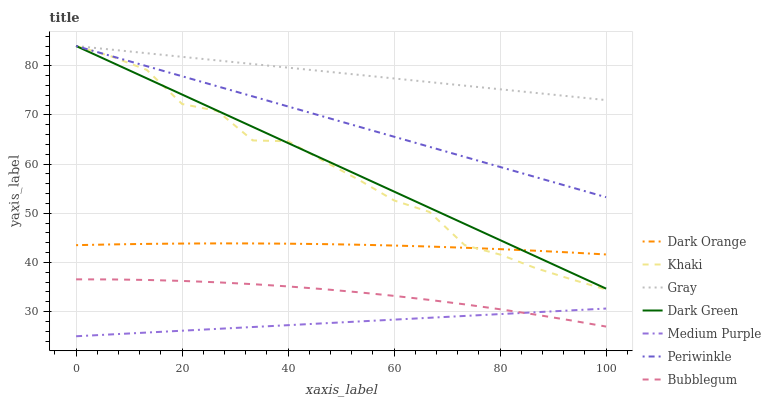Does Medium Purple have the minimum area under the curve?
Answer yes or no. Yes. Does Gray have the maximum area under the curve?
Answer yes or no. Yes. Does Khaki have the minimum area under the curve?
Answer yes or no. No. Does Khaki have the maximum area under the curve?
Answer yes or no. No. Is Medium Purple the smoothest?
Answer yes or no. Yes. Is Khaki the roughest?
Answer yes or no. Yes. Is Gray the smoothest?
Answer yes or no. No. Is Gray the roughest?
Answer yes or no. No. Does Medium Purple have the lowest value?
Answer yes or no. Yes. Does Khaki have the lowest value?
Answer yes or no. No. Does Dark Green have the highest value?
Answer yes or no. Yes. Does Bubblegum have the highest value?
Answer yes or no. No. Is Dark Orange less than Periwinkle?
Answer yes or no. Yes. Is Dark Orange greater than Bubblegum?
Answer yes or no. Yes. Does Dark Orange intersect Khaki?
Answer yes or no. Yes. Is Dark Orange less than Khaki?
Answer yes or no. No. Is Dark Orange greater than Khaki?
Answer yes or no. No. Does Dark Orange intersect Periwinkle?
Answer yes or no. No. 